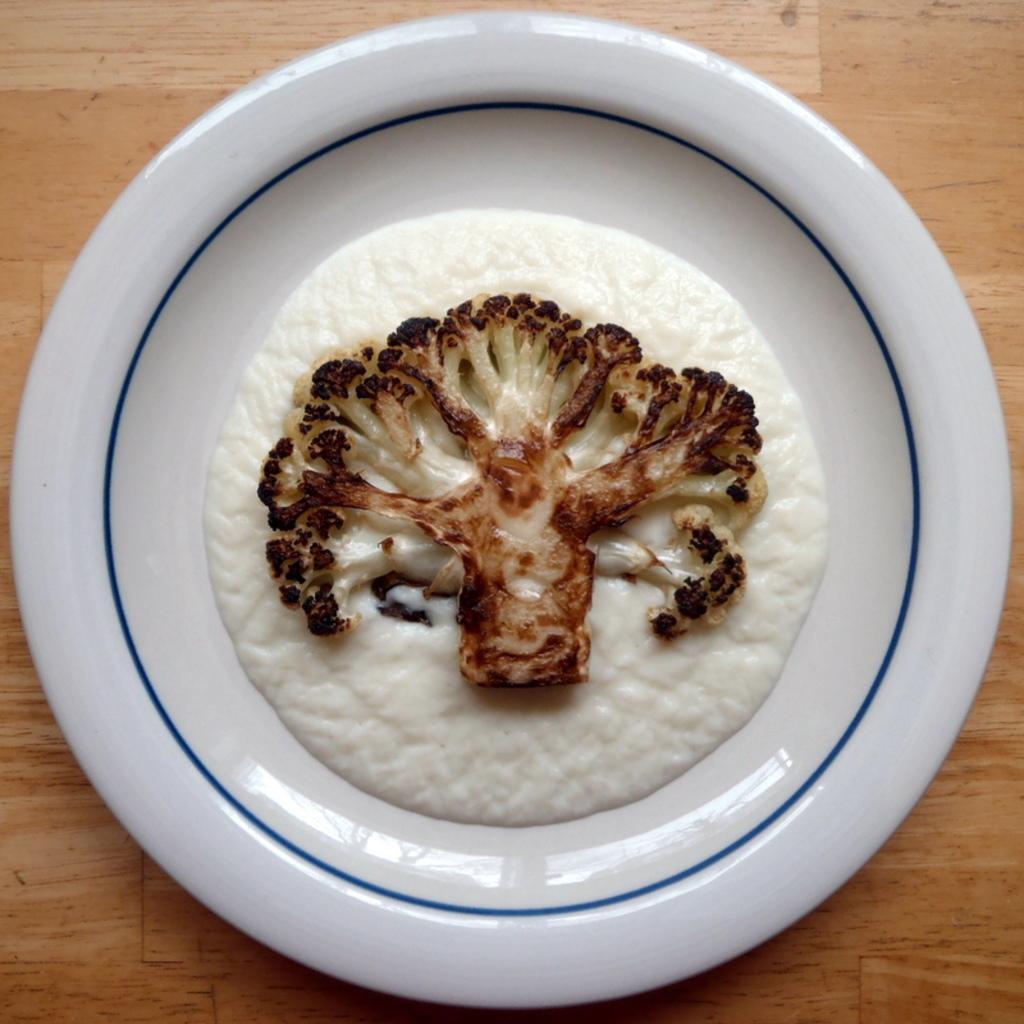How would you summarize this image in a sentence or two? In this image I can see the food in the white color plate and the plate is on the brown color surface. 